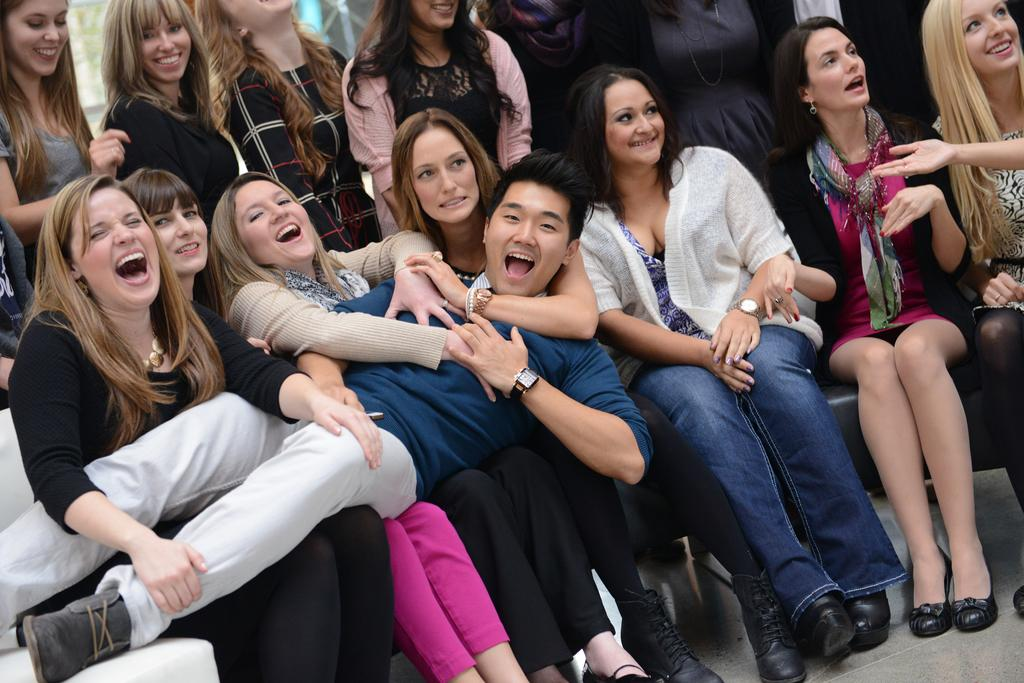How many women are present in the image? There are many women in the image. What are the women doing in the image? The women are sitting on chairs and holding a man. Are there any women standing in the image? Yes, there are few women standing in the background. What month does the zoo event take place in the image? There is no zoo or event present in the image; it features women sitting on chairs and holding a man. 